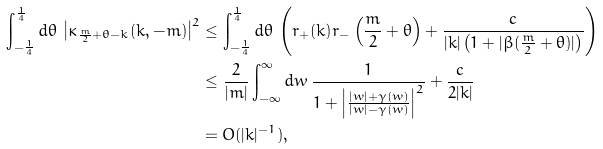Convert formula to latex. <formula><loc_0><loc_0><loc_500><loc_500>\int _ { - \frac { 1 } { 4 } } ^ { \frac { 1 } { 4 } } d \theta \, \left | \kappa _ { \frac { m } { 2 } + \theta - k } ( k , - m ) \right | ^ { 2 } & \leq \int _ { - \frac { 1 } { 4 } } ^ { \frac { 1 } { 4 } } d \theta \, \left ( r _ { + } ( k ) r _ { - } \left ( \frac { m } { 2 } + \theta \right ) + \frac { c } { | k | \left ( 1 + | \beta ( \frac { m } { 2 } + \theta ) | \right ) } \right ) \\ & \leq \frac { 2 } { | m | } \int _ { - \infty } ^ { \infty } d w \, \frac { 1 } { 1 + \left | \frac { | w | + \gamma ( w ) } { | w | - \gamma ( w ) } \right | ^ { 2 } } + \frac { c } { 2 | k | } \\ & = O ( | k | ^ { - 1 } ) ,</formula> 